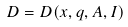Convert formula to latex. <formula><loc_0><loc_0><loc_500><loc_500>D = D ( x , q , A , I )</formula> 